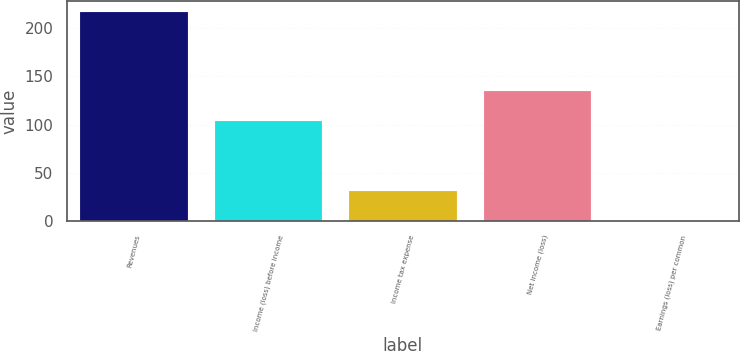Convert chart to OTSL. <chart><loc_0><loc_0><loc_500><loc_500><bar_chart><fcel>Revenues<fcel>Income (loss) before income<fcel>Income tax expense<fcel>Net income (loss)<fcel>Earnings (loss) per common<nl><fcel>217<fcel>104<fcel>31<fcel>135<fcel>0.45<nl></chart> 